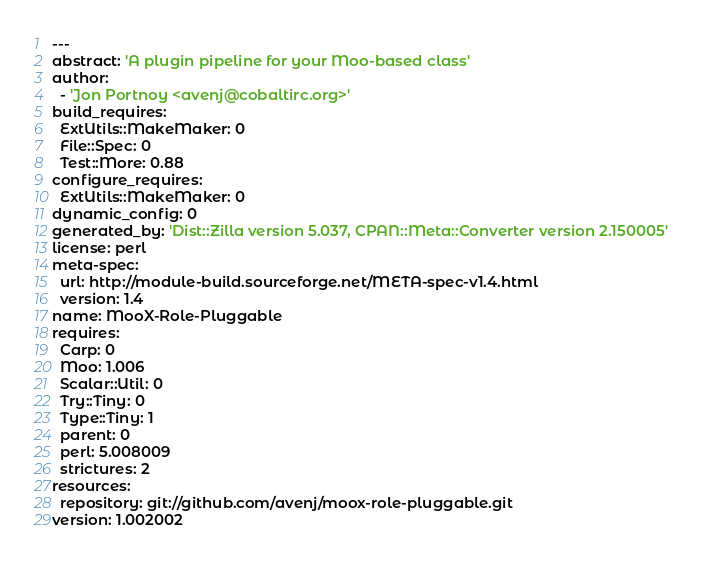<code> <loc_0><loc_0><loc_500><loc_500><_YAML_>---
abstract: 'A plugin pipeline for your Moo-based class'
author:
  - 'Jon Portnoy <avenj@cobaltirc.org>'
build_requires:
  ExtUtils::MakeMaker: 0
  File::Spec: 0
  Test::More: 0.88
configure_requires:
  ExtUtils::MakeMaker: 0
dynamic_config: 0
generated_by: 'Dist::Zilla version 5.037, CPAN::Meta::Converter version 2.150005'
license: perl
meta-spec:
  url: http://module-build.sourceforge.net/META-spec-v1.4.html
  version: 1.4
name: MooX-Role-Pluggable
requires:
  Carp: 0
  Moo: 1.006
  Scalar::Util: 0
  Try::Tiny: 0
  Type::Tiny: 1
  parent: 0
  perl: 5.008009
  strictures: 2
resources:
  repository: git://github.com/avenj/moox-role-pluggable.git
version: 1.002002
</code> 